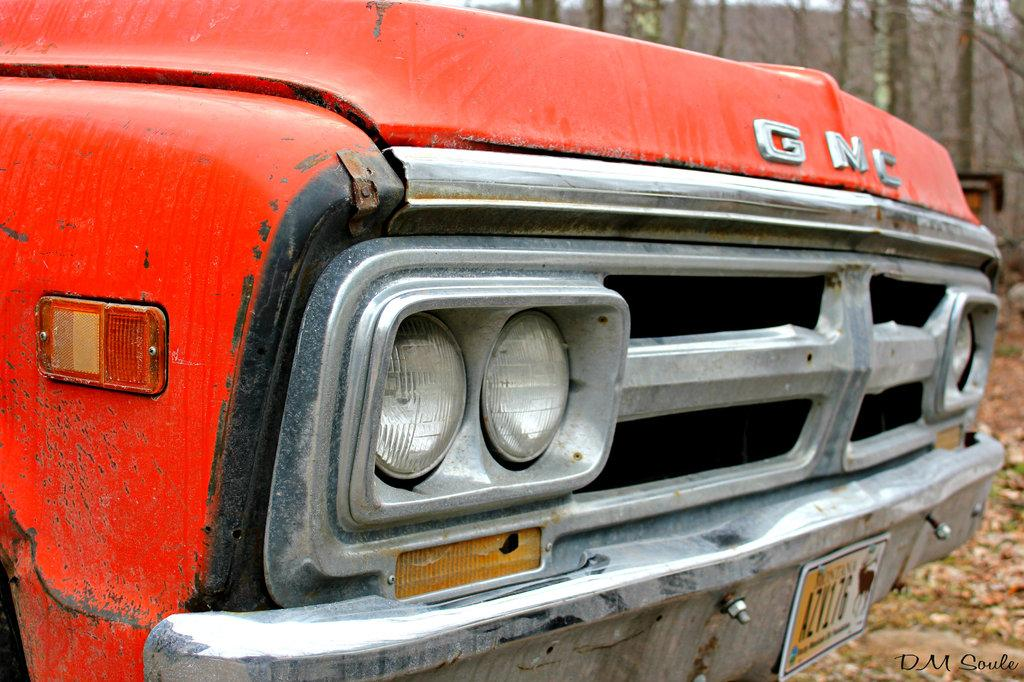What is the main subject of the image? There is a car in the center of the image. What color is the car? The car is red in color. What can be seen in the background of the image? There are trees in the background of the image. What is present on the ground in the image? Dry leaves are present on the ground in the image. What type of quilt is draped over the car in the image? There is no quilt present in the image; it features a red car with trees in the background and dry leaves on the ground. 